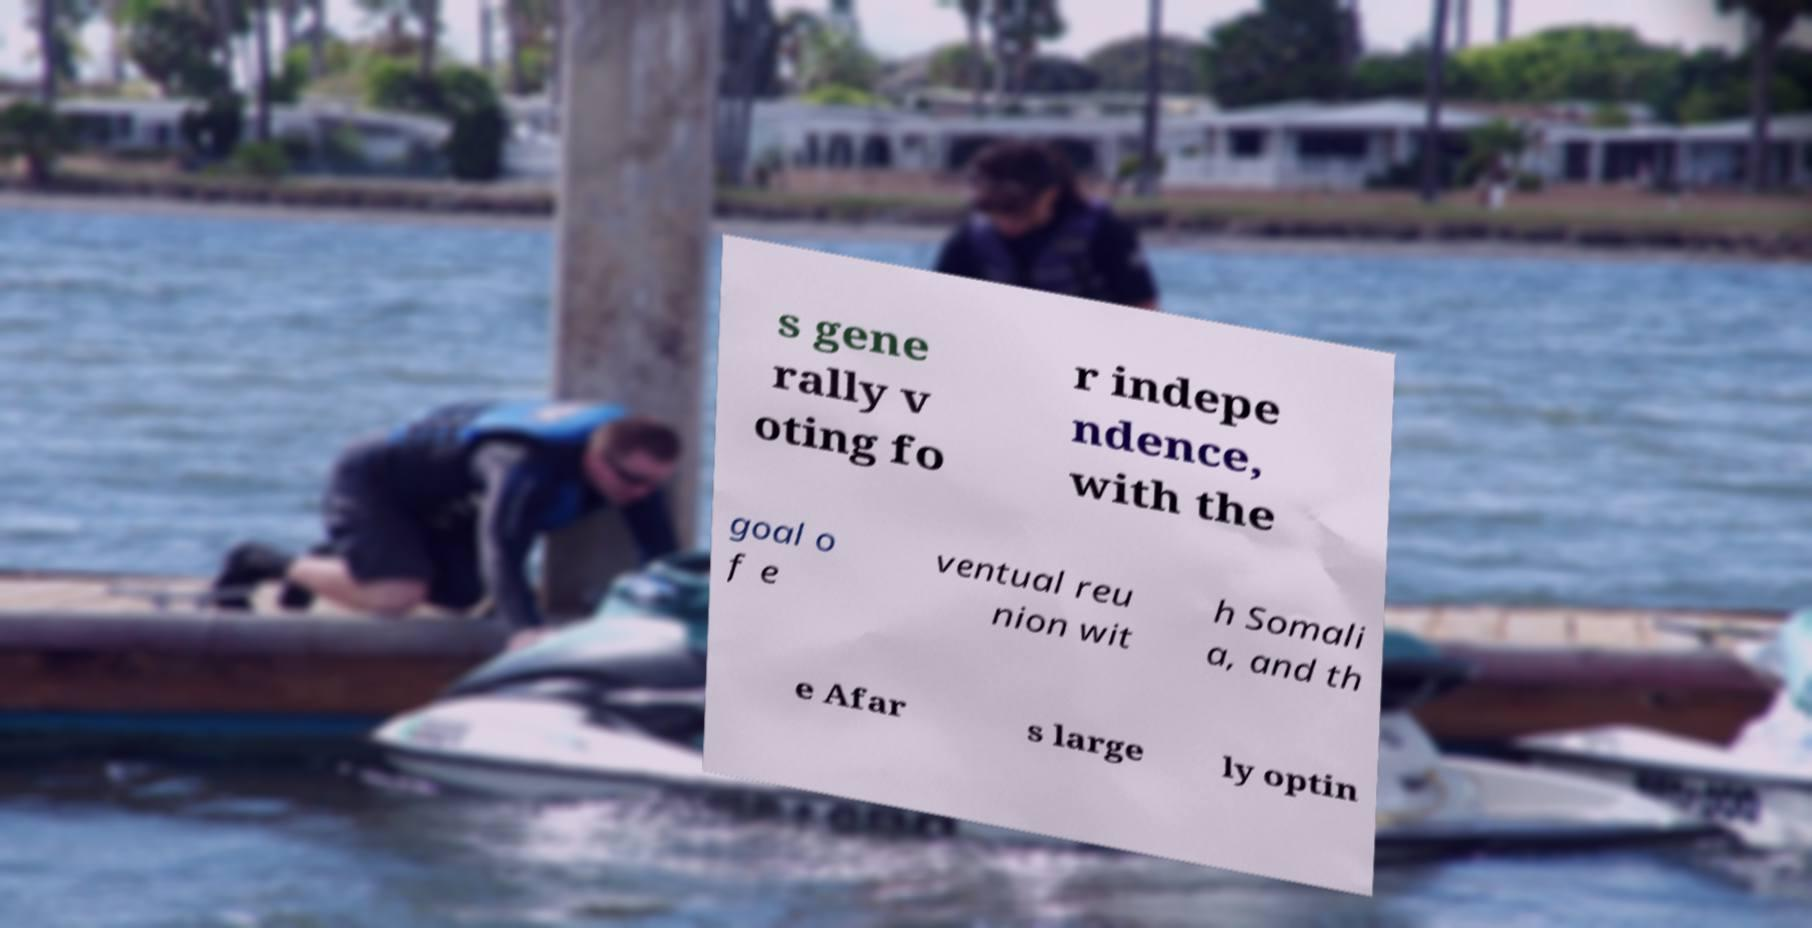Can you accurately transcribe the text from the provided image for me? s gene rally v oting fo r indepe ndence, with the goal o f e ventual reu nion wit h Somali a, and th e Afar s large ly optin 